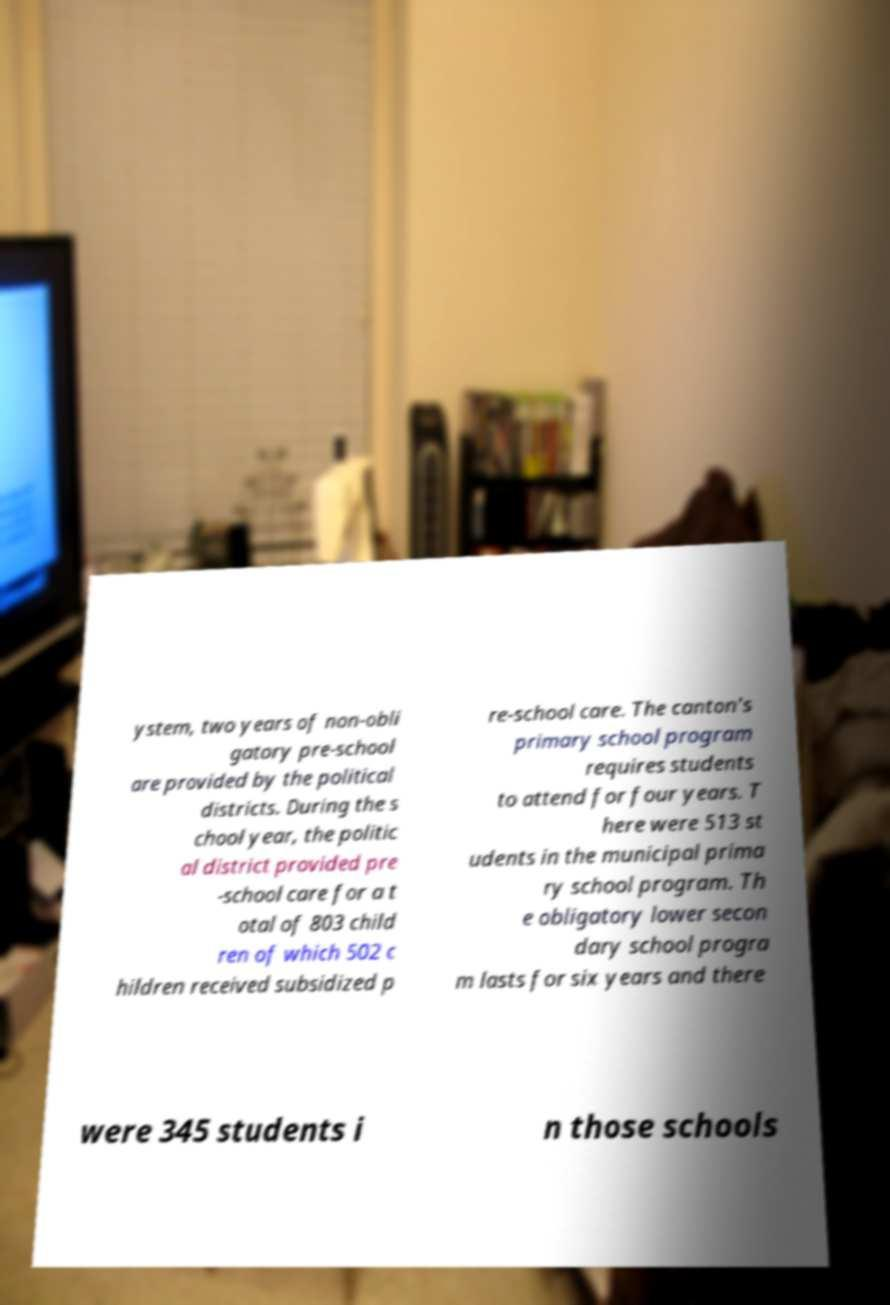Could you assist in decoding the text presented in this image and type it out clearly? ystem, two years of non-obli gatory pre-school are provided by the political districts. During the s chool year, the politic al district provided pre -school care for a t otal of 803 child ren of which 502 c hildren received subsidized p re-school care. The canton's primary school program requires students to attend for four years. T here were 513 st udents in the municipal prima ry school program. Th e obligatory lower secon dary school progra m lasts for six years and there were 345 students i n those schools 